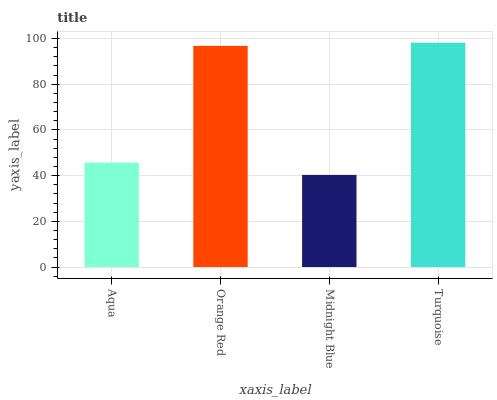Is Midnight Blue the minimum?
Answer yes or no. Yes. Is Turquoise the maximum?
Answer yes or no. Yes. Is Orange Red the minimum?
Answer yes or no. No. Is Orange Red the maximum?
Answer yes or no. No. Is Orange Red greater than Aqua?
Answer yes or no. Yes. Is Aqua less than Orange Red?
Answer yes or no. Yes. Is Aqua greater than Orange Red?
Answer yes or no. No. Is Orange Red less than Aqua?
Answer yes or no. No. Is Orange Red the high median?
Answer yes or no. Yes. Is Aqua the low median?
Answer yes or no. Yes. Is Turquoise the high median?
Answer yes or no. No. Is Turquoise the low median?
Answer yes or no. No. 